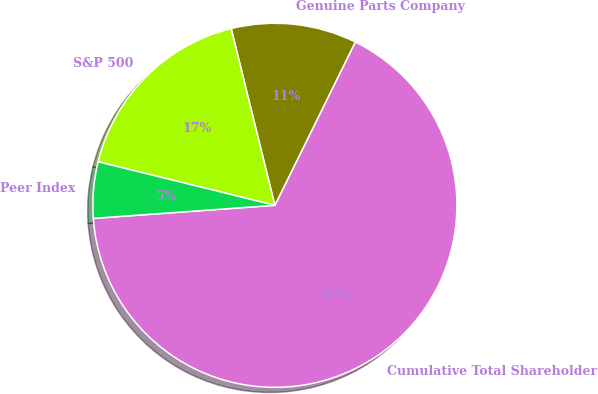Convert chart to OTSL. <chart><loc_0><loc_0><loc_500><loc_500><pie_chart><fcel>Cumulative Total Shareholder<fcel>Genuine Parts Company<fcel>S&P 500<fcel>Peer Index<nl><fcel>66.57%<fcel>11.14%<fcel>17.3%<fcel>4.99%<nl></chart> 